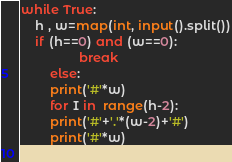<code> <loc_0><loc_0><loc_500><loc_500><_Python_>while True: 
	h , w=map(int, input().split())
	if (h==0) and (w==0): 
                break
        else:
		print('#'*w)
		for I in  range(h-2):
		print('#'+'.'*(w-2)+'#')
		print('#'*w)
 
</code> 